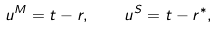Convert formula to latex. <formula><loc_0><loc_0><loc_500><loc_500>u ^ { M } = t - r , \quad u ^ { S } = t - r ^ { * } ,</formula> 